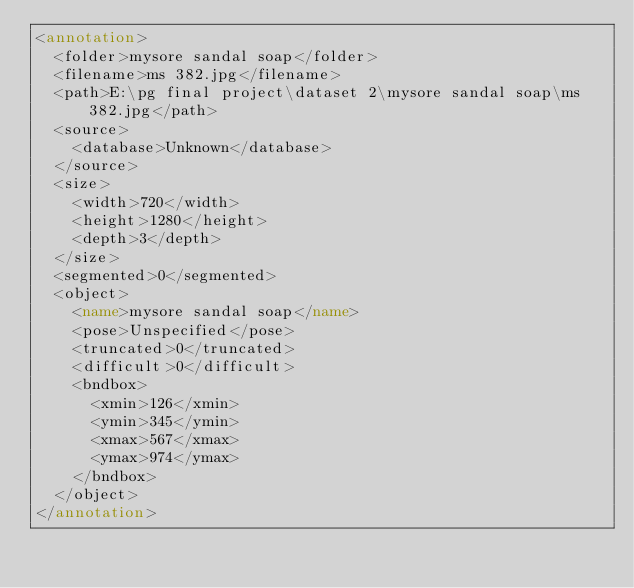<code> <loc_0><loc_0><loc_500><loc_500><_XML_><annotation>
	<folder>mysore sandal soap</folder>
	<filename>ms 382.jpg</filename>
	<path>E:\pg final project\dataset 2\mysore sandal soap\ms 382.jpg</path>
	<source>
		<database>Unknown</database>
	</source>
	<size>
		<width>720</width>
		<height>1280</height>
		<depth>3</depth>
	</size>
	<segmented>0</segmented>
	<object>
		<name>mysore sandal soap</name>
		<pose>Unspecified</pose>
		<truncated>0</truncated>
		<difficult>0</difficult>
		<bndbox>
			<xmin>126</xmin>
			<ymin>345</ymin>
			<xmax>567</xmax>
			<ymax>974</ymax>
		</bndbox>
	</object>
</annotation>
</code> 